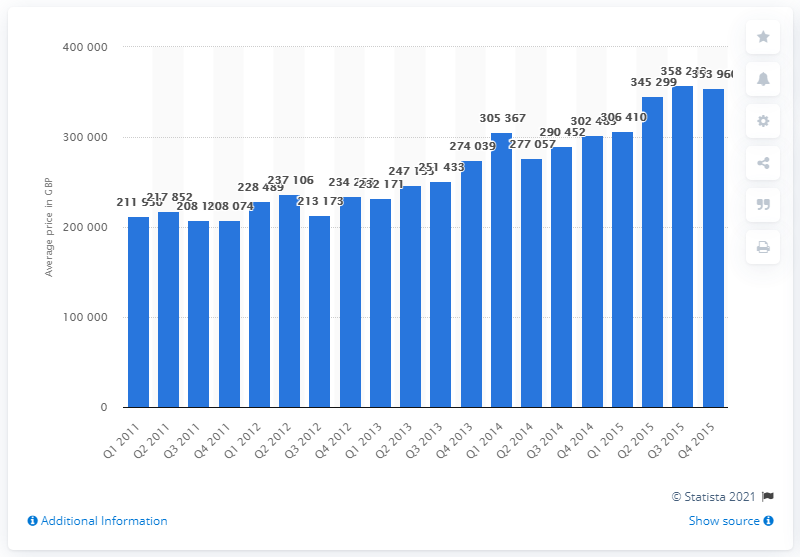Outline some significant characteristics in this image. In Greater London between 1946 and 1960, the average price of a terraced house was approximately 277057. In the fourth quarter of 2015, the average price of a terraced house was 353,960. 